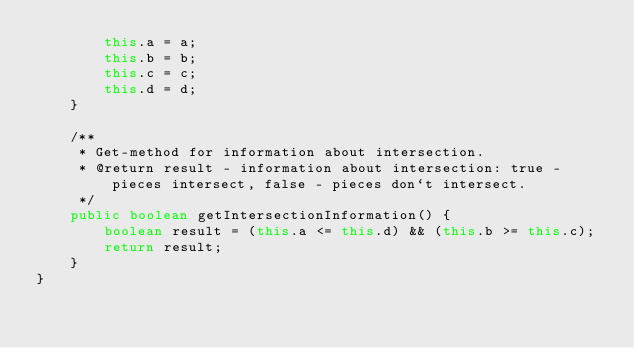Convert code to text. <code><loc_0><loc_0><loc_500><loc_500><_Java_>        this.a = a;
        this.b = b;
        this.c = c;
        this.d = d;
    }

    /**
     * Get-method for information about intersection.
     * @return result - information about intersection: true - pieces intersect, false - pieces don`t intersect.
     */
    public boolean getIntersectionInformation() {
        boolean result = (this.a <= this.d) && (this.b >= this.c);
        return result;
    }
}</code> 